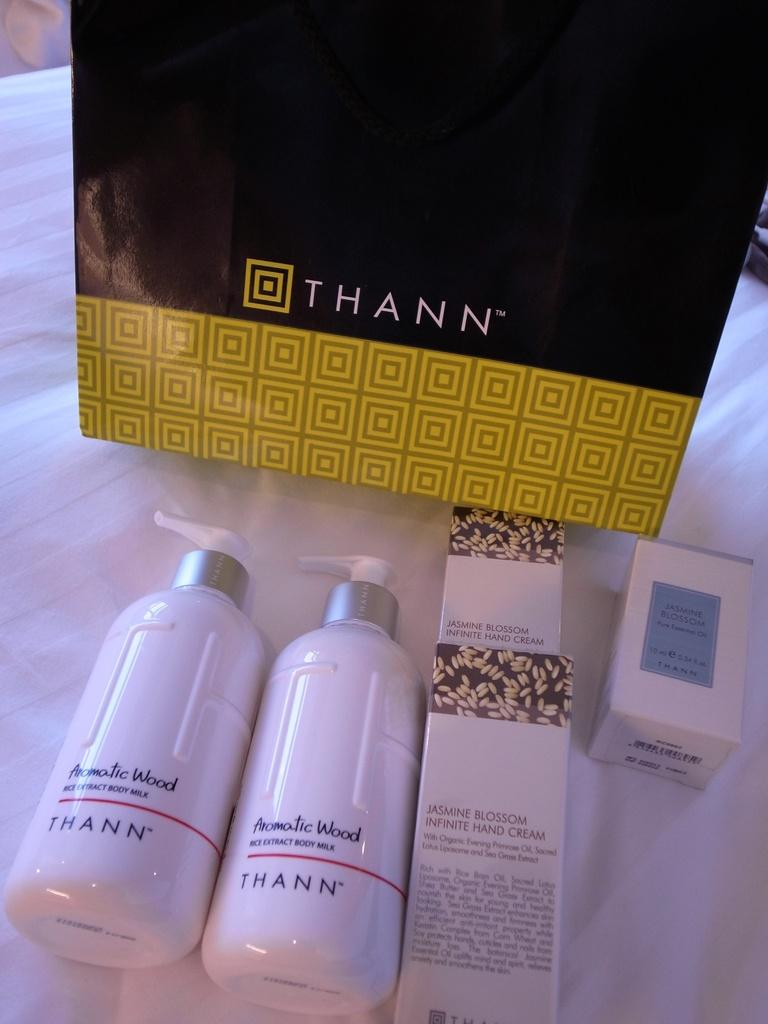<image>
Present a compact description of the photo's key features. Two pump bottles of Thann Body Milk in front of a black and gold box. 